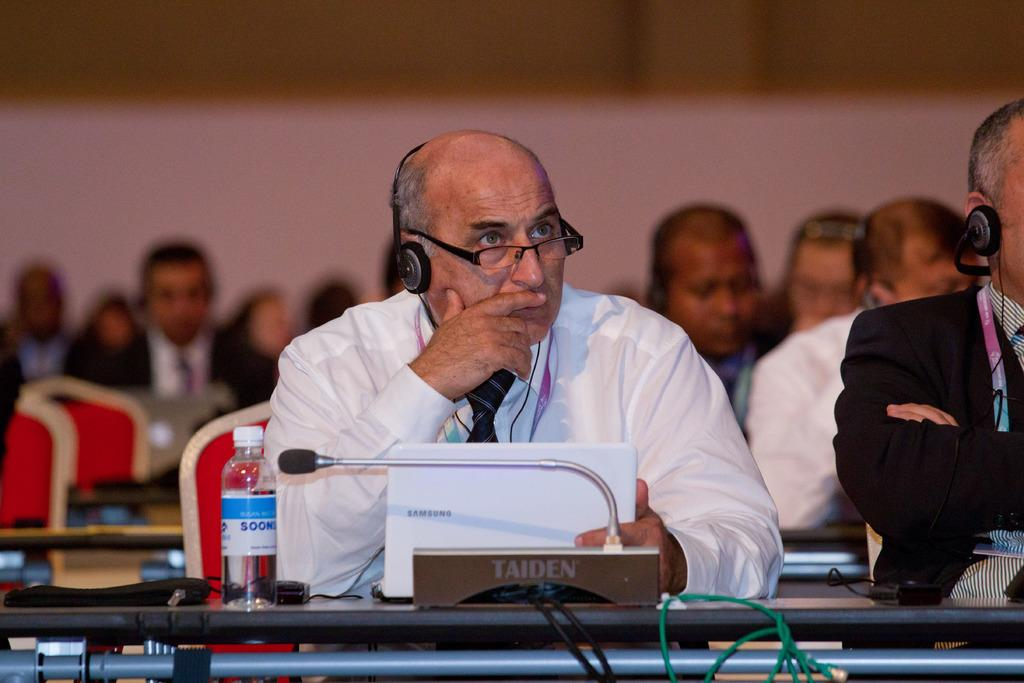What are the people in the image doing? The people in the image are sitting on chairs. What objects are on the tables in the image? Tables in the image have laptops, microphones, disposable bottles, and cables. What might the people be using the laptops for? The laptops might be used for work or communication purposes. What is the purpose of the microphones on the tables? The microphones on the tables might be used for recording or amplifying sound. Can you tell me how many times the people in the image burst into laughter? There is no indication of laughter or any such emotion in the image, so it cannot be determined. 